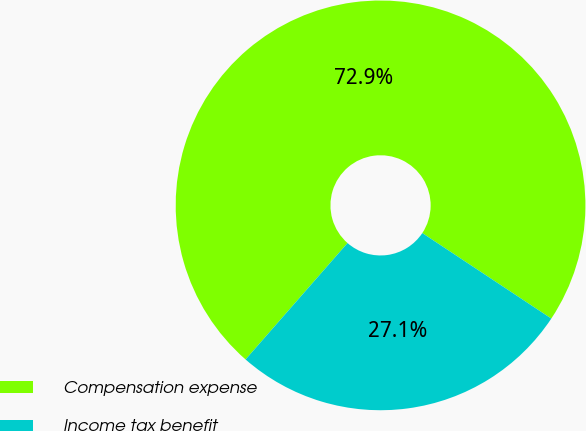Convert chart. <chart><loc_0><loc_0><loc_500><loc_500><pie_chart><fcel>Compensation expense<fcel>Income tax benefit<nl><fcel>72.87%<fcel>27.13%<nl></chart> 